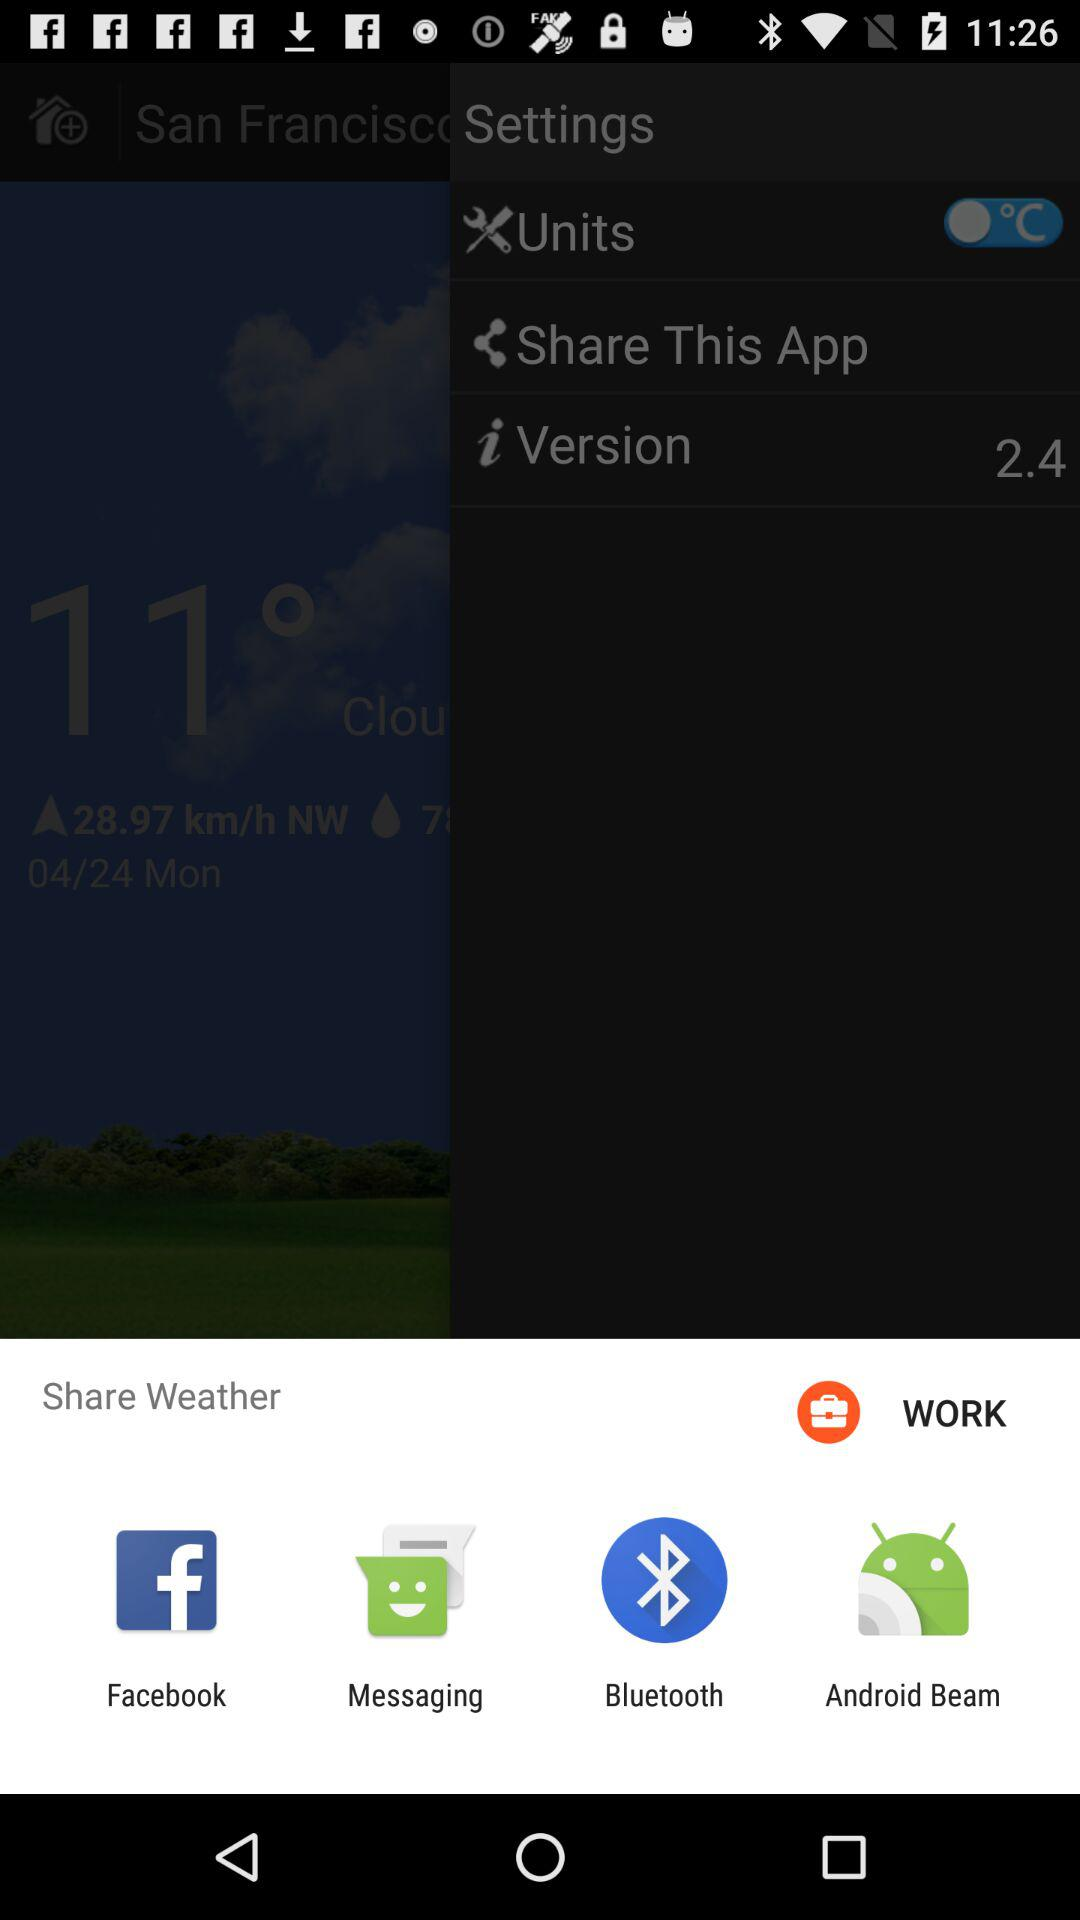Which applications can be used to share weather? The applications that can be used to share weather are "Facebook", "Messaging", "Bluetooth" and "Android Beam". 